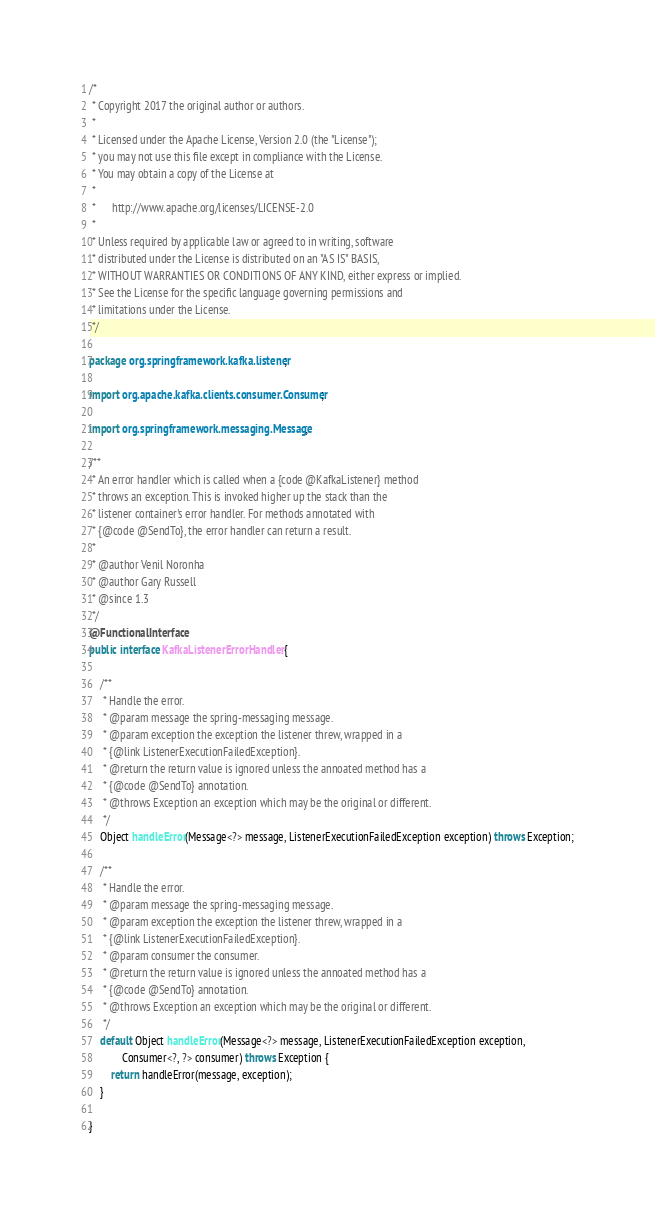Convert code to text. <code><loc_0><loc_0><loc_500><loc_500><_Java_>/*
 * Copyright 2017 the original author or authors.
 *
 * Licensed under the Apache License, Version 2.0 (the "License");
 * you may not use this file except in compliance with the License.
 * You may obtain a copy of the License at
 *
 *      http://www.apache.org/licenses/LICENSE-2.0
 *
 * Unless required by applicable law or agreed to in writing, software
 * distributed under the License is distributed on an "AS IS" BASIS,
 * WITHOUT WARRANTIES OR CONDITIONS OF ANY KIND, either express or implied.
 * See the License for the specific language governing permissions and
 * limitations under the License.
 */

package org.springframework.kafka.listener;

import org.apache.kafka.clients.consumer.Consumer;

import org.springframework.messaging.Message;

/**
 * An error handler which is called when a {code @KafkaListener} method
 * throws an exception. This is invoked higher up the stack than the
 * listener container's error handler. For methods annotated with
 * {@code @SendTo}, the error handler can return a result.
 *
 * @author Venil Noronha
 * @author Gary Russell
 * @since 1.3
 */
@FunctionalInterface
public interface KafkaListenerErrorHandler {

	/**
	 * Handle the error.
	 * @param message the spring-messaging message.
	 * @param exception the exception the listener threw, wrapped in a
	 * {@link ListenerExecutionFailedException}.
	 * @return the return value is ignored unless the annoated method has a
	 * {@code @SendTo} annotation.
	 * @throws Exception an exception which may be the original or different.
	 */
	Object handleError(Message<?> message, ListenerExecutionFailedException exception) throws Exception;

	/**
	 * Handle the error.
	 * @param message the spring-messaging message.
	 * @param exception the exception the listener threw, wrapped in a
	 * {@link ListenerExecutionFailedException}.
	 * @param consumer the consumer.
	 * @return the return value is ignored unless the annoated method has a
	 * {@code @SendTo} annotation.
	 * @throws Exception an exception which may be the original or different.
	 */
	default Object handleError(Message<?> message, ListenerExecutionFailedException exception,
			Consumer<?, ?> consumer) throws Exception {
		return handleError(message, exception);
	}

}
</code> 